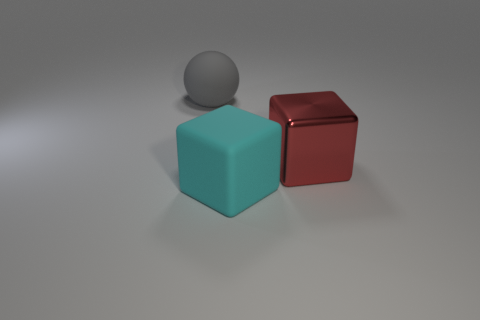Add 1 big red things. How many objects exist? 4 Subtract all balls. How many objects are left? 2 Add 2 large gray rubber balls. How many large gray rubber balls are left? 3 Add 1 big purple cubes. How many big purple cubes exist? 1 Subtract 0 cyan cylinders. How many objects are left? 3 Subtract all big metal things. Subtract all big matte objects. How many objects are left? 0 